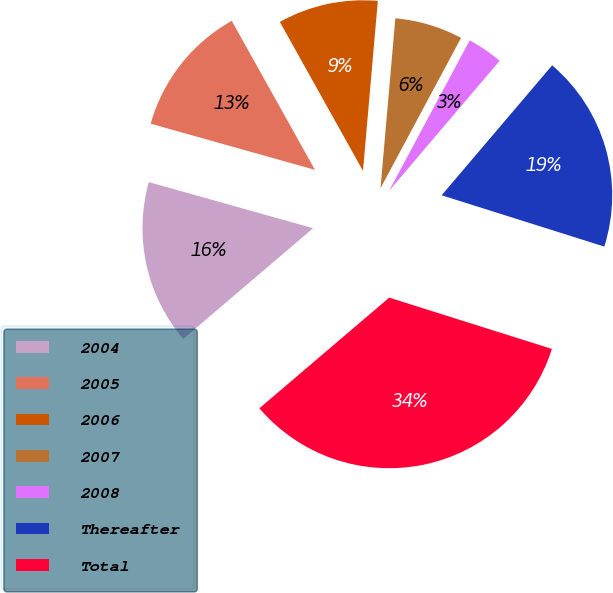Convert chart. <chart><loc_0><loc_0><loc_500><loc_500><pie_chart><fcel>2004<fcel>2005<fcel>2006<fcel>2007<fcel>2008<fcel>Thereafter<fcel>Total<nl><fcel>15.59%<fcel>12.54%<fcel>9.49%<fcel>6.44%<fcel>3.39%<fcel>18.64%<fcel>33.9%<nl></chart> 